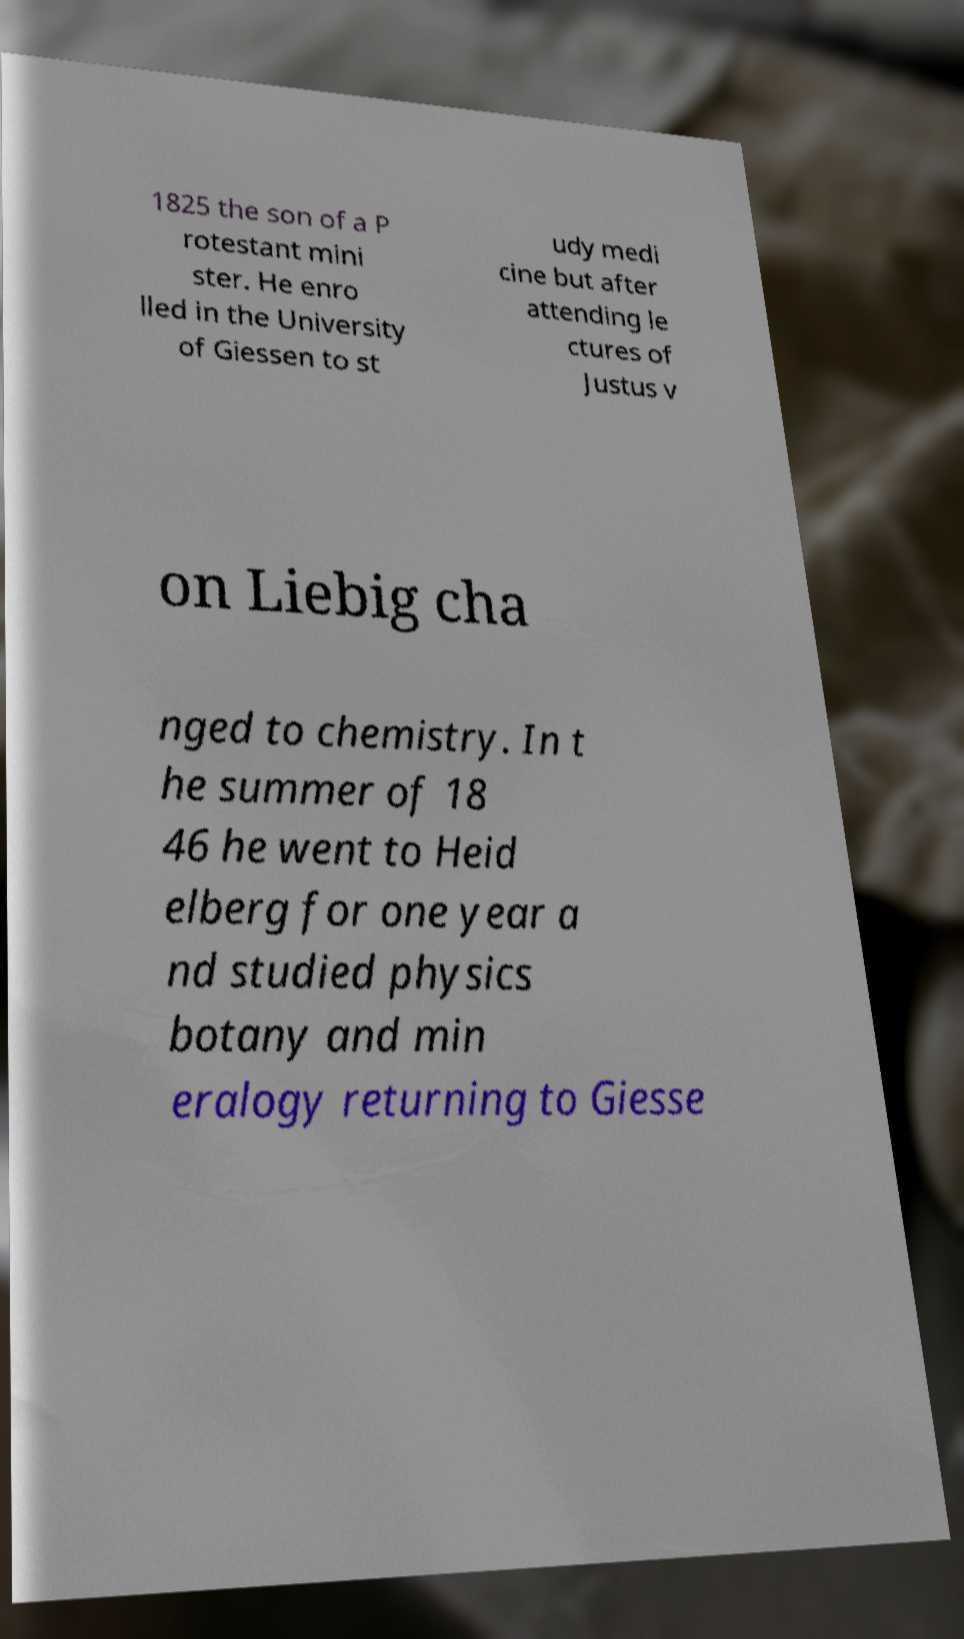There's text embedded in this image that I need extracted. Can you transcribe it verbatim? 1825 the son of a P rotestant mini ster. He enro lled in the University of Giessen to st udy medi cine but after attending le ctures of Justus v on Liebig cha nged to chemistry. In t he summer of 18 46 he went to Heid elberg for one year a nd studied physics botany and min eralogy returning to Giesse 